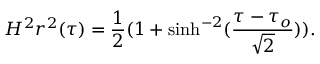<formula> <loc_0><loc_0><loc_500><loc_500>H ^ { 2 } r ^ { 2 } ( \tau ) = \frac { 1 } { 2 } ( 1 + \sinh ^ { - 2 } ( \frac { \tau - \tau _ { o } } { \sqrt { 2 } } ) ) .</formula> 